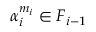<formula> <loc_0><loc_0><loc_500><loc_500>\alpha _ { i } ^ { m _ { i } } \in F _ { i - 1 }</formula> 